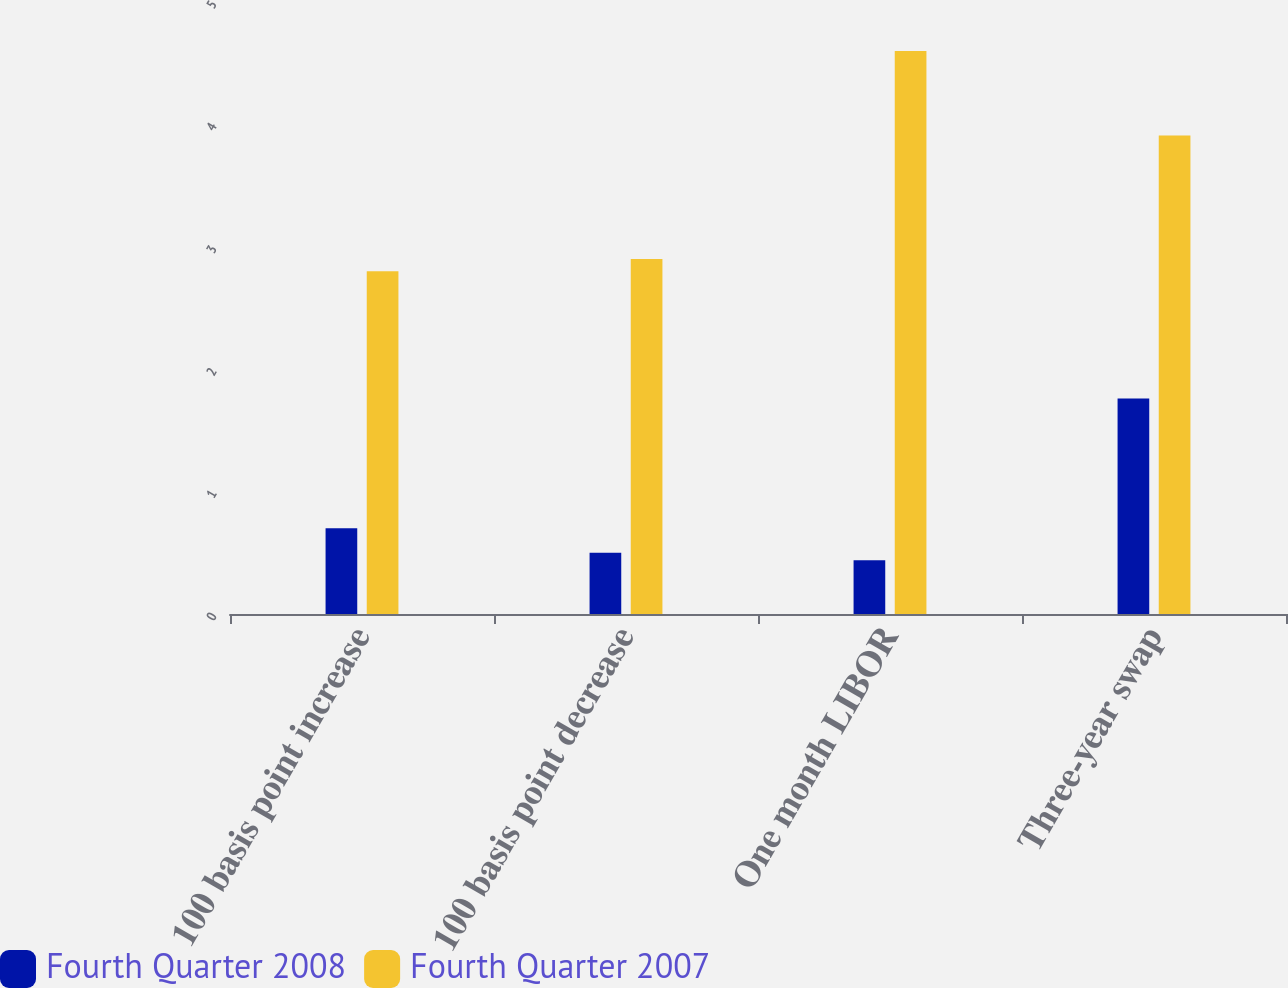Convert chart. <chart><loc_0><loc_0><loc_500><loc_500><stacked_bar_chart><ecel><fcel>100 basis point increase<fcel>100 basis point decrease<fcel>One month LIBOR<fcel>Three-year swap<nl><fcel>Fourth Quarter 2008<fcel>0.7<fcel>0.5<fcel>0.44<fcel>1.76<nl><fcel>Fourth Quarter 2007<fcel>2.8<fcel>2.9<fcel>4.6<fcel>3.91<nl></chart> 